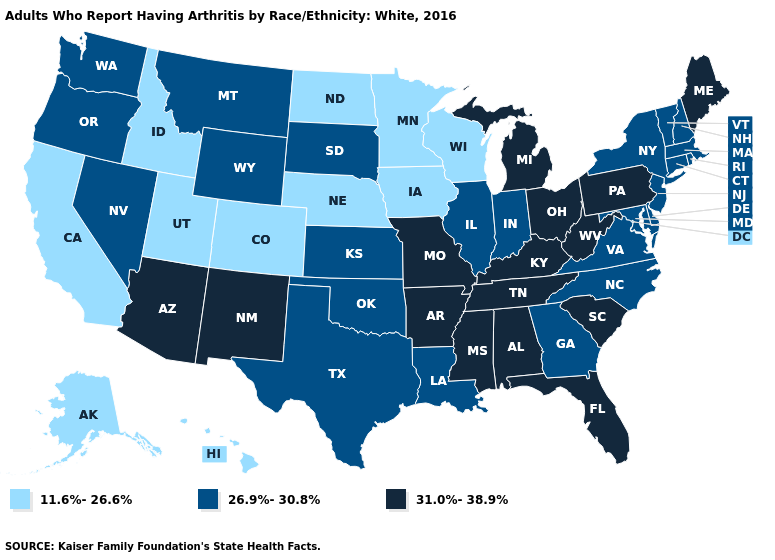Among the states that border Wisconsin , does Illinois have the highest value?
Answer briefly. No. What is the value of New York?
Be succinct. 26.9%-30.8%. What is the lowest value in the USA?
Quick response, please. 11.6%-26.6%. What is the lowest value in the South?
Give a very brief answer. 26.9%-30.8%. Does Montana have the same value as New Hampshire?
Quick response, please. Yes. What is the value of West Virginia?
Give a very brief answer. 31.0%-38.9%. Does Virginia have the highest value in the USA?
Short answer required. No. Does Iowa have the highest value in the USA?
Be succinct. No. Which states have the highest value in the USA?
Concise answer only. Alabama, Arizona, Arkansas, Florida, Kentucky, Maine, Michigan, Mississippi, Missouri, New Mexico, Ohio, Pennsylvania, South Carolina, Tennessee, West Virginia. Among the states that border Illinois , which have the lowest value?
Answer briefly. Iowa, Wisconsin. Does the map have missing data?
Keep it brief. No. What is the highest value in the South ?
Answer briefly. 31.0%-38.9%. What is the value of Ohio?
Concise answer only. 31.0%-38.9%. Name the states that have a value in the range 11.6%-26.6%?
Be succinct. Alaska, California, Colorado, Hawaii, Idaho, Iowa, Minnesota, Nebraska, North Dakota, Utah, Wisconsin. What is the value of Illinois?
Concise answer only. 26.9%-30.8%. 